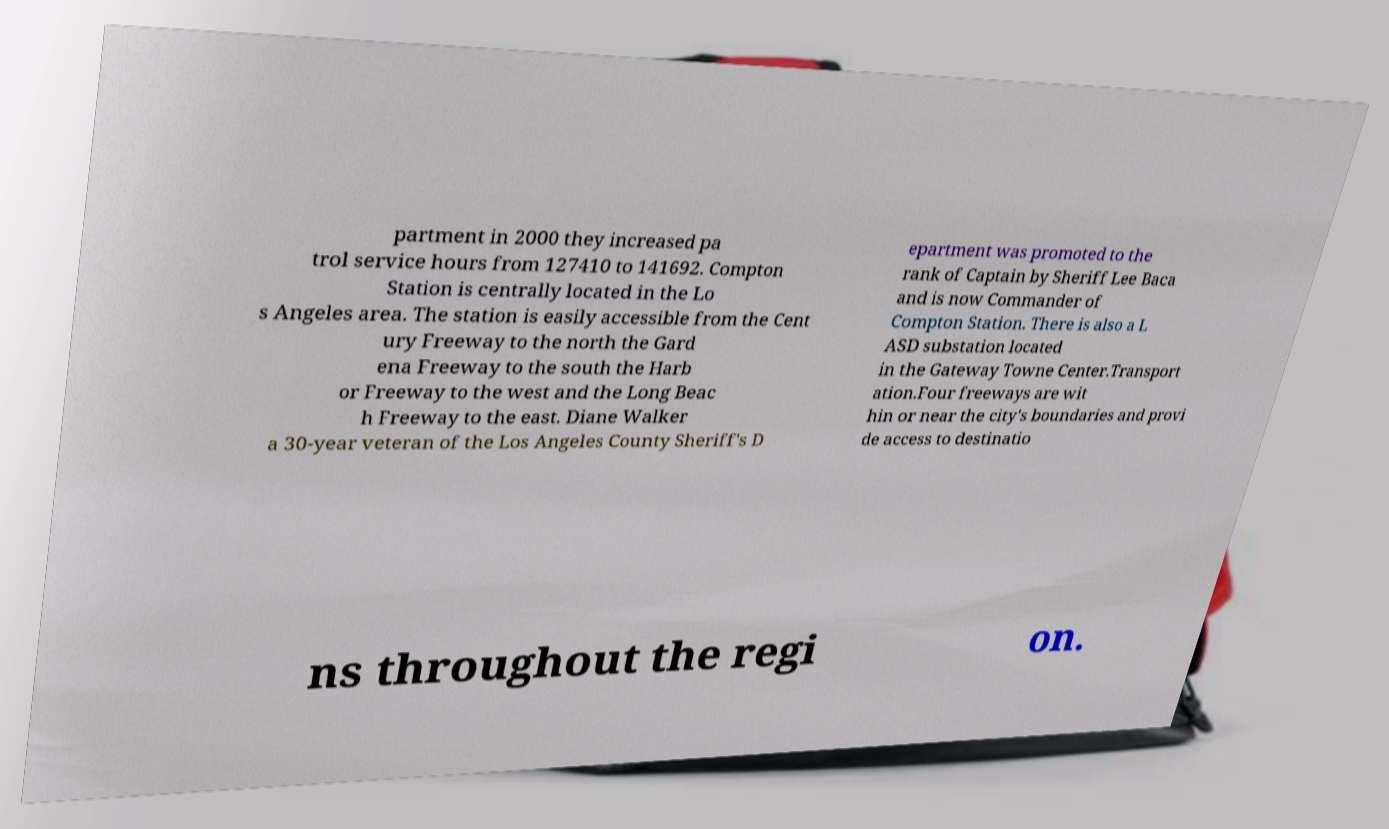Can you read and provide the text displayed in the image?This photo seems to have some interesting text. Can you extract and type it out for me? partment in 2000 they increased pa trol service hours from 127410 to 141692. Compton Station is centrally located in the Lo s Angeles area. The station is easily accessible from the Cent ury Freeway to the north the Gard ena Freeway to the south the Harb or Freeway to the west and the Long Beac h Freeway to the east. Diane Walker a 30-year veteran of the Los Angeles County Sheriff's D epartment was promoted to the rank of Captain by Sheriff Lee Baca and is now Commander of Compton Station. There is also a L ASD substation located in the Gateway Towne Center.Transport ation.Four freeways are wit hin or near the city's boundaries and provi de access to destinatio ns throughout the regi on. 